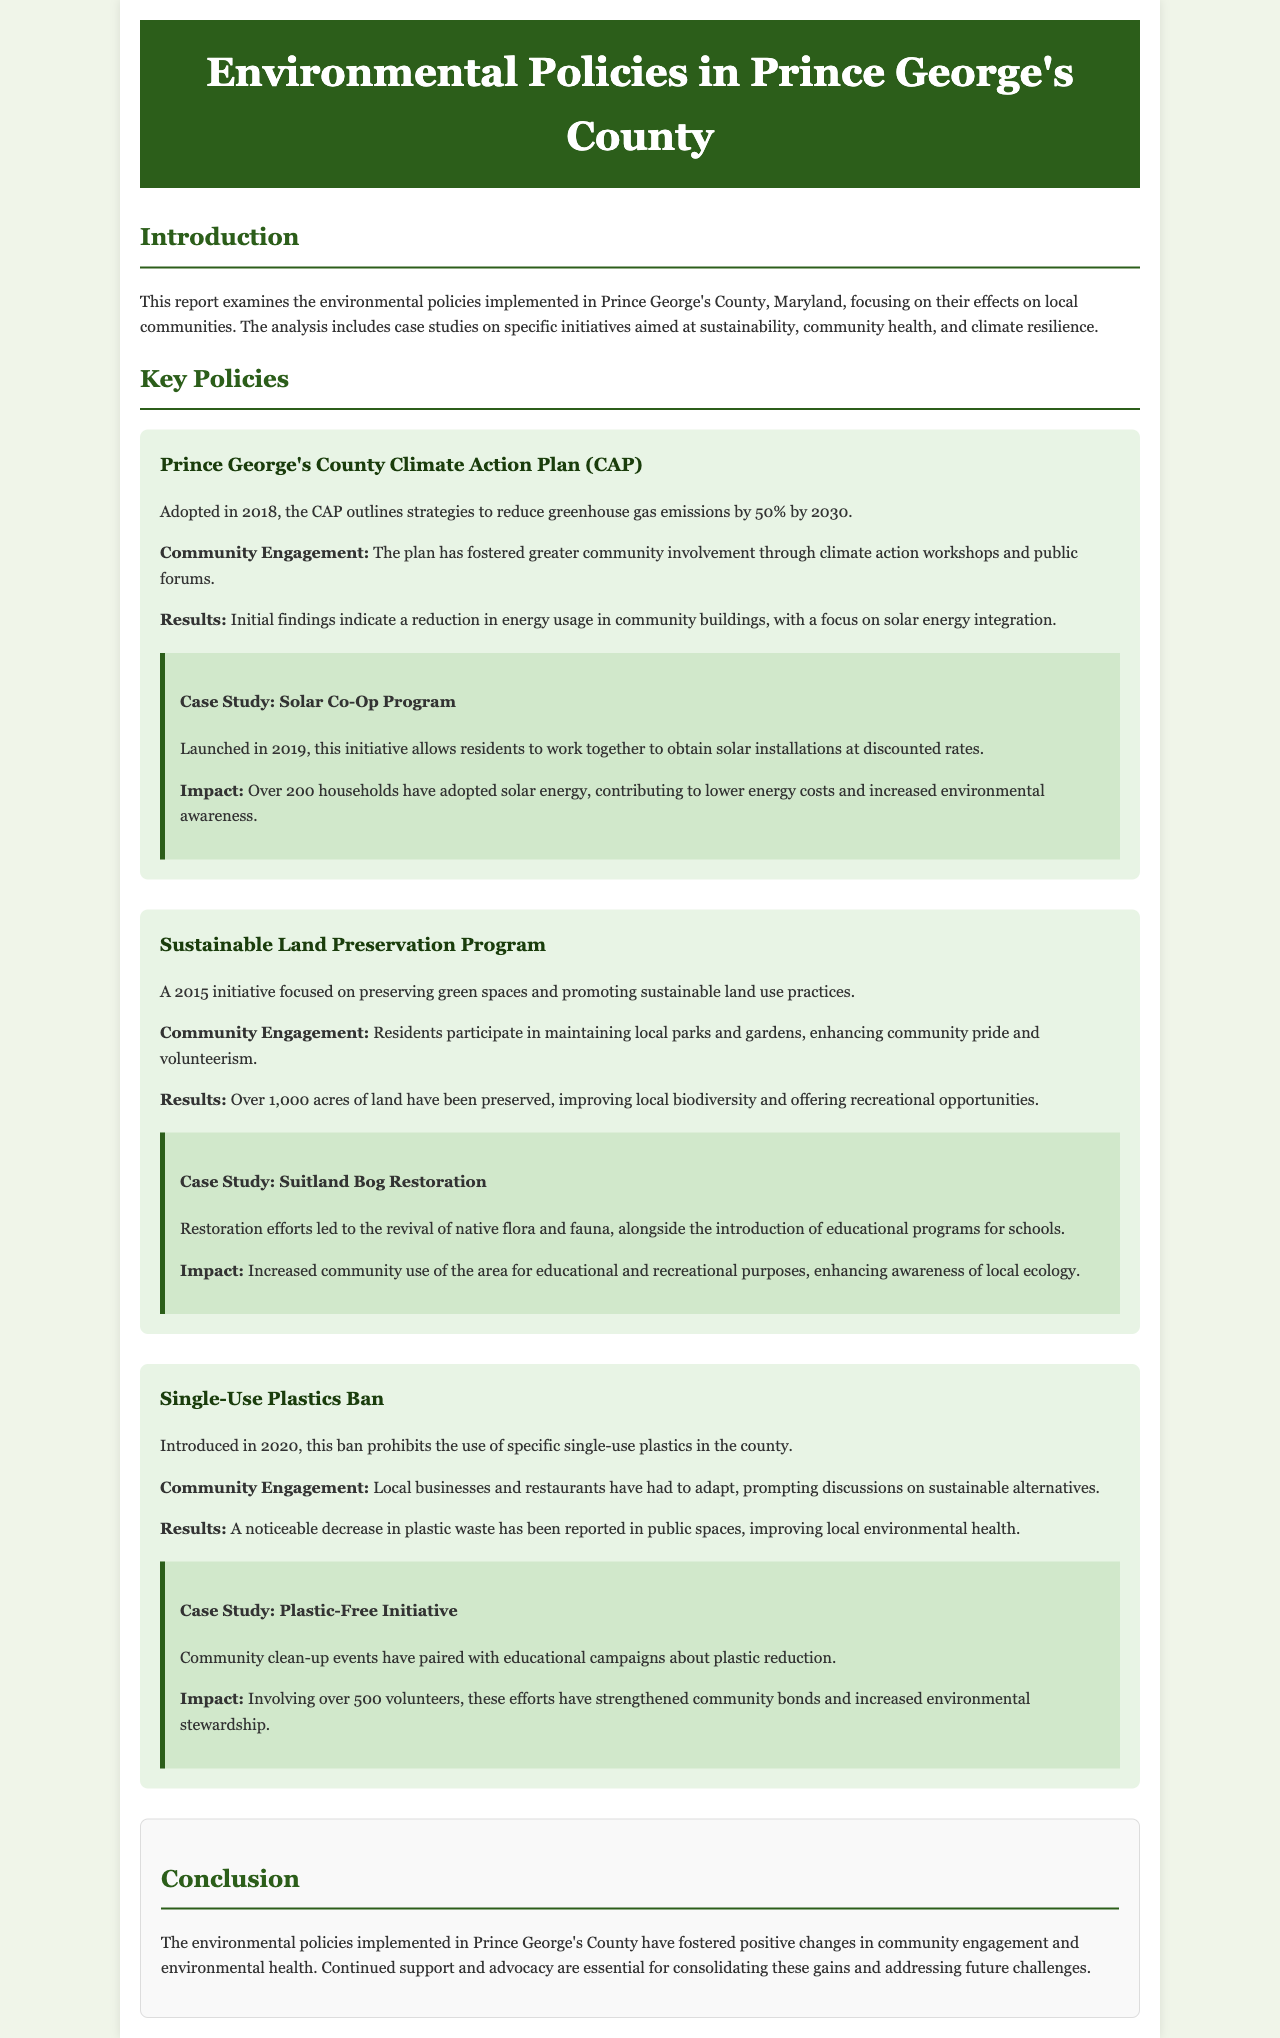what is the title of the report? The title of the report is mentioned in the header section of the document.
Answer: Environmental Policies in Prince George's County when was the Climate Action Plan adopted? The adoption year of the Climate Action Plan is specified in the report.
Answer: 2018 how many acres of land have been preserved under the Sustainable Land Preservation Program? The report provides specific numbers related to the outcomes of the program.
Answer: Over 1,000 acres how many households have adopted solar energy in the Solar Co-Op Program? The number of households adopting solar energy is detailed in the case study section about the program.
Answer: Over 200 households what environmental issue is addressed by the Single-Use Plastics Ban? The single-use plastics ban's purpose is described in its policy section.
Answer: Plastic waste how did the Community Engagement change due to the Climate Action Plan? The document outlines the community's involvement as a result of the plan.
Answer: Greater community involvement what type of community event was paired with the Plastic-Free Initiative? The report refers to community activities linked to the initiative for enhancing engagement.
Answer: Clean-up events which case study focuses on local ecology awareness? The case study relates to environmental education efforts mentioned in the document.
Answer: Suitland Bog Restoration 